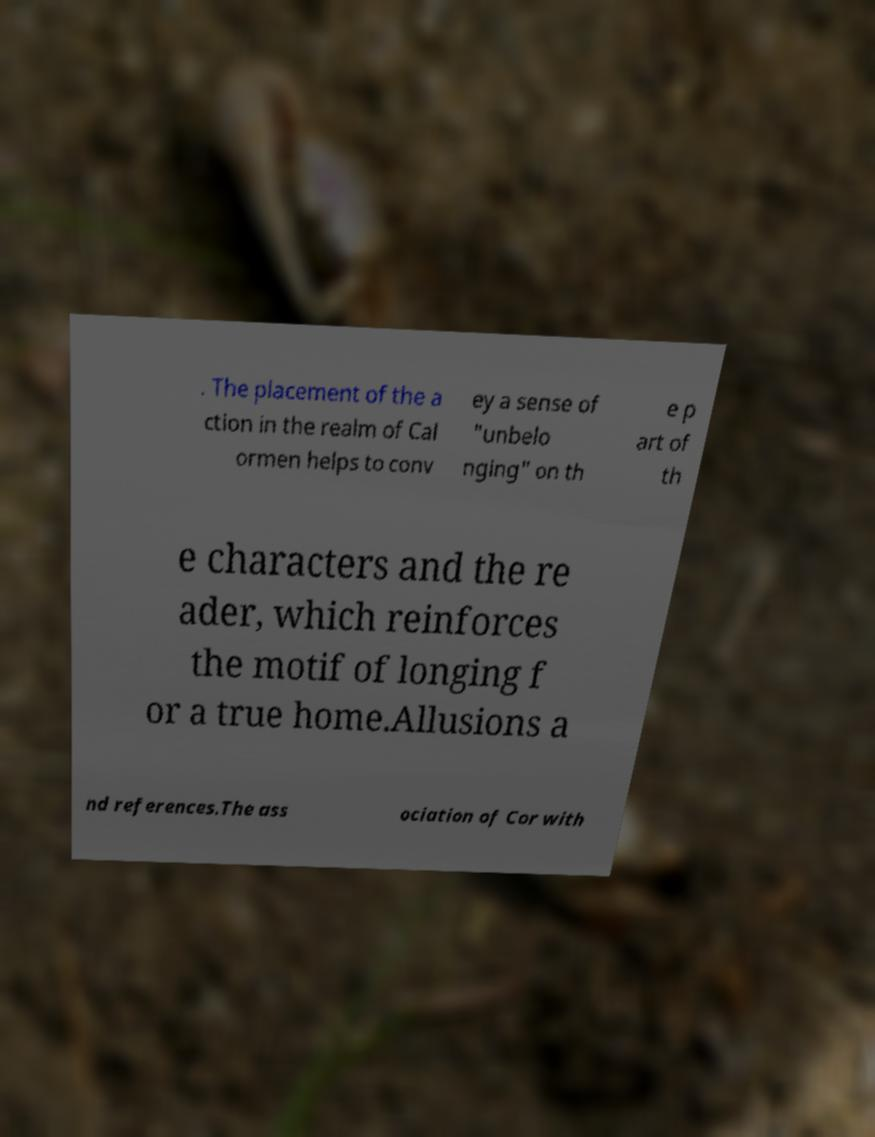For documentation purposes, I need the text within this image transcribed. Could you provide that? . The placement of the a ction in the realm of Cal ormen helps to conv ey a sense of "unbelo nging" on th e p art of th e characters and the re ader, which reinforces the motif of longing f or a true home.Allusions a nd references.The ass ociation of Cor with 